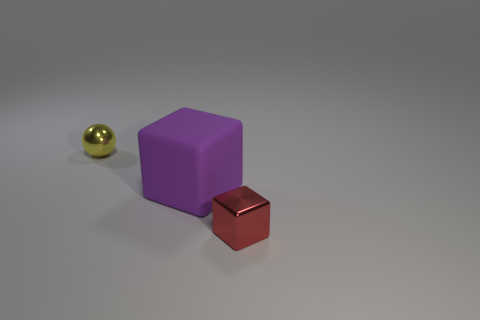Are there any other things that have the same material as the purple block?
Keep it short and to the point. No. The purple rubber thing that is the same shape as the red shiny object is what size?
Ensure brevity in your answer.  Large. There is a metal thing left of the large cube; what shape is it?
Make the answer very short. Sphere. There is another thing that is the same size as the red shiny object; what color is it?
Provide a short and direct response. Yellow. Do the small object that is behind the small metal block and the large purple cube have the same material?
Offer a terse response. No. There is a object that is both to the left of the red object and in front of the yellow metallic thing; what size is it?
Your answer should be very brief. Large. There is a purple object right of the yellow ball; what size is it?
Give a very brief answer. Large. There is a matte object left of the small thing to the right of the tiny metallic object left of the red object; what is its shape?
Your response must be concise. Cube. How many other objects are the same shape as the tiny yellow object?
Provide a short and direct response. 0. What number of metal objects are either small yellow blocks or purple objects?
Your response must be concise. 0. 